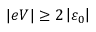<formula> <loc_0><loc_0><loc_500><loc_500>| e V | \geq 2 \left | \varepsilon _ { 0 } \right |</formula> 